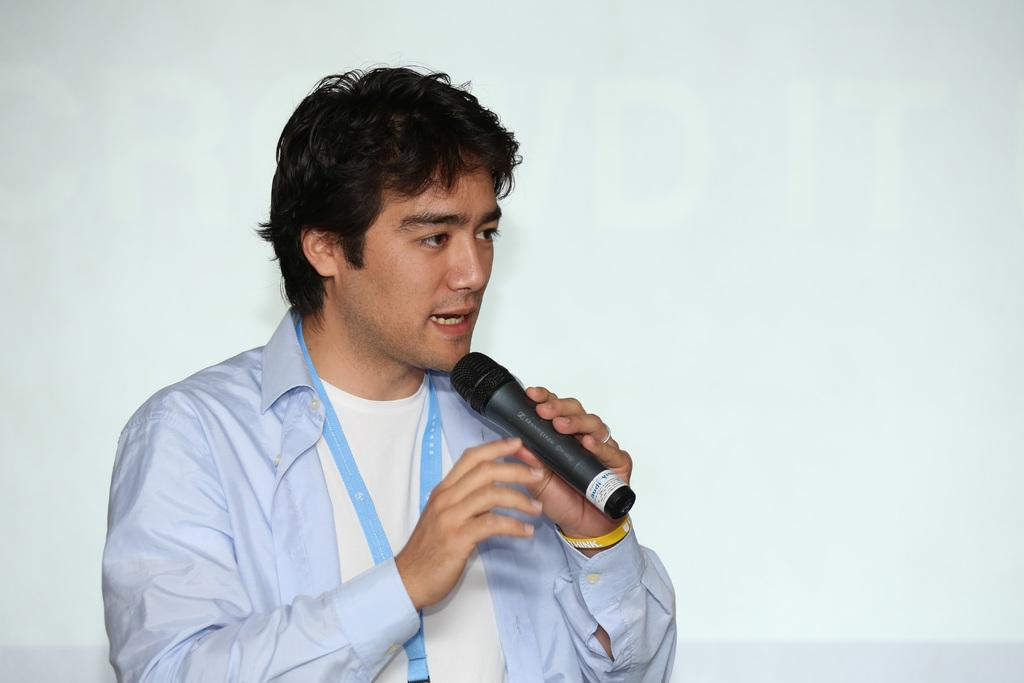What is the main subject of the image? The main subject of the image is a man. What is the man holding in his left hand? The man is holding a mic in his left hand. What color is the man's heart in the image? There is no visible heart in the image, so we cannot determine its color. 